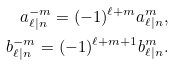<formula> <loc_0><loc_0><loc_500><loc_500>a ^ { - m } _ { \ell | n } = ( - 1 ) ^ { \ell + m } a ^ { m } _ { \ell | n } , \\ b ^ { - m } _ { \ell | n } = ( - 1 ) ^ { \ell + m + 1 } b ^ { m } _ { \ell | n } .</formula> 